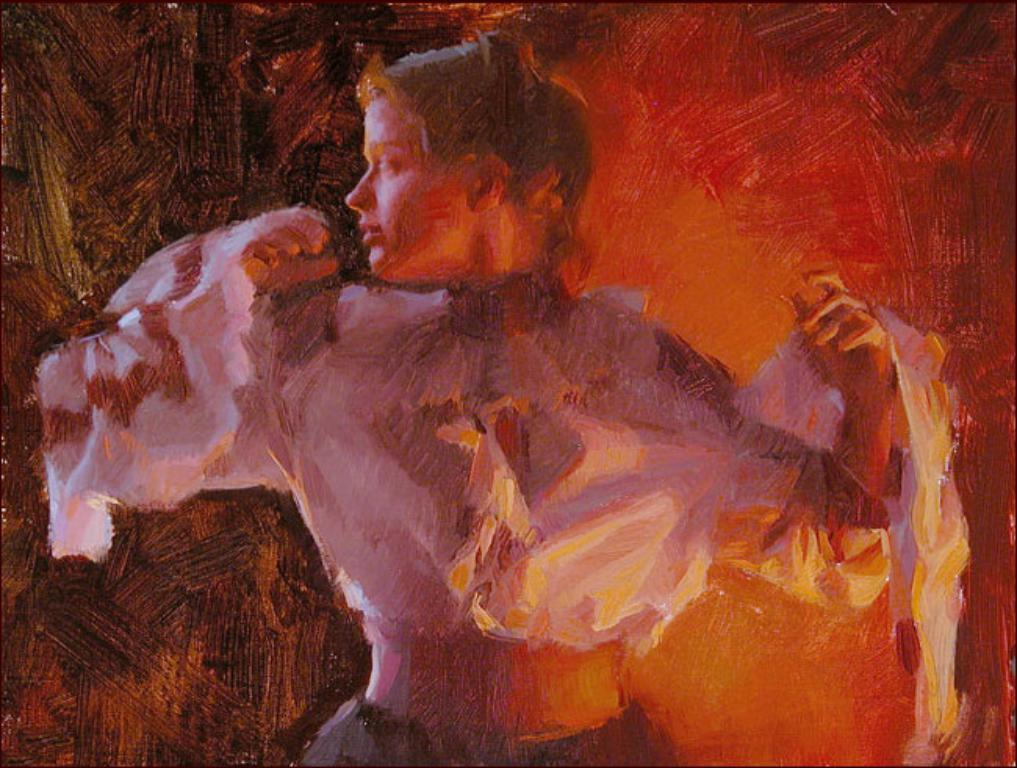What is depicted in the image? There is a painting of a woman in the image. What type of umbrella is the woman holding in the painting? There is no umbrella present in the painting; it depicts a woman without any umbrella. What tool might the artist have used to create the painting? While it's possible that the artist used a brush to create the painting, we cannot determine this from the image alone. 